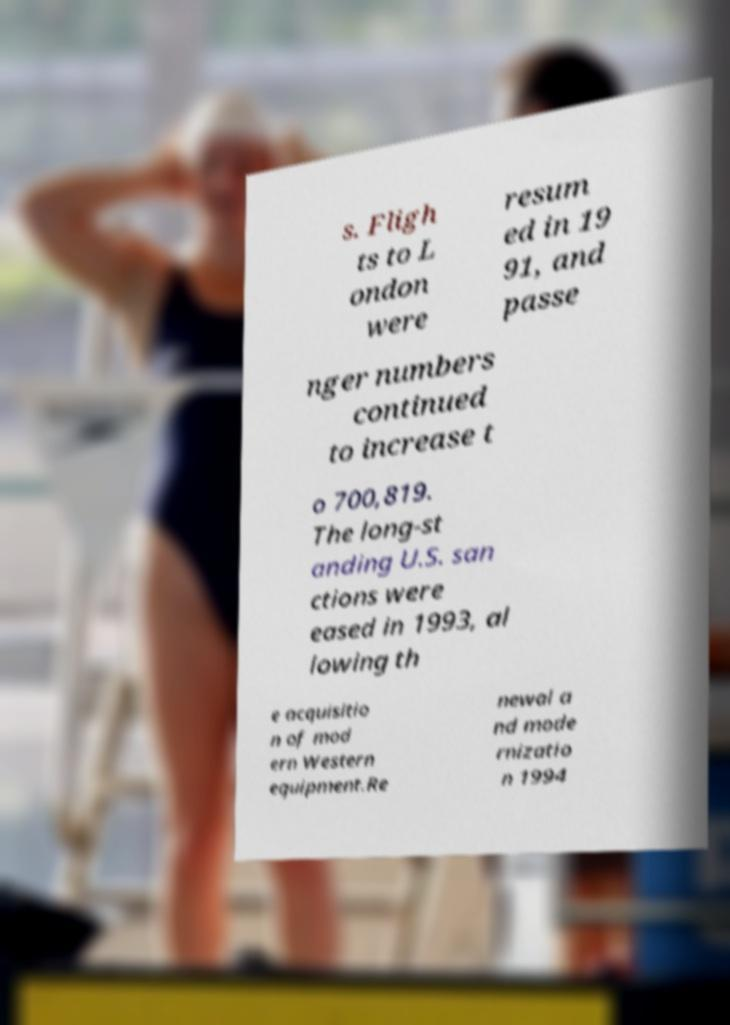Could you extract and type out the text from this image? s. Fligh ts to L ondon were resum ed in 19 91, and passe nger numbers continued to increase t o 700,819. The long-st anding U.S. san ctions were eased in 1993, al lowing th e acquisitio n of mod ern Western equipment.Re newal a nd mode rnizatio n 1994 